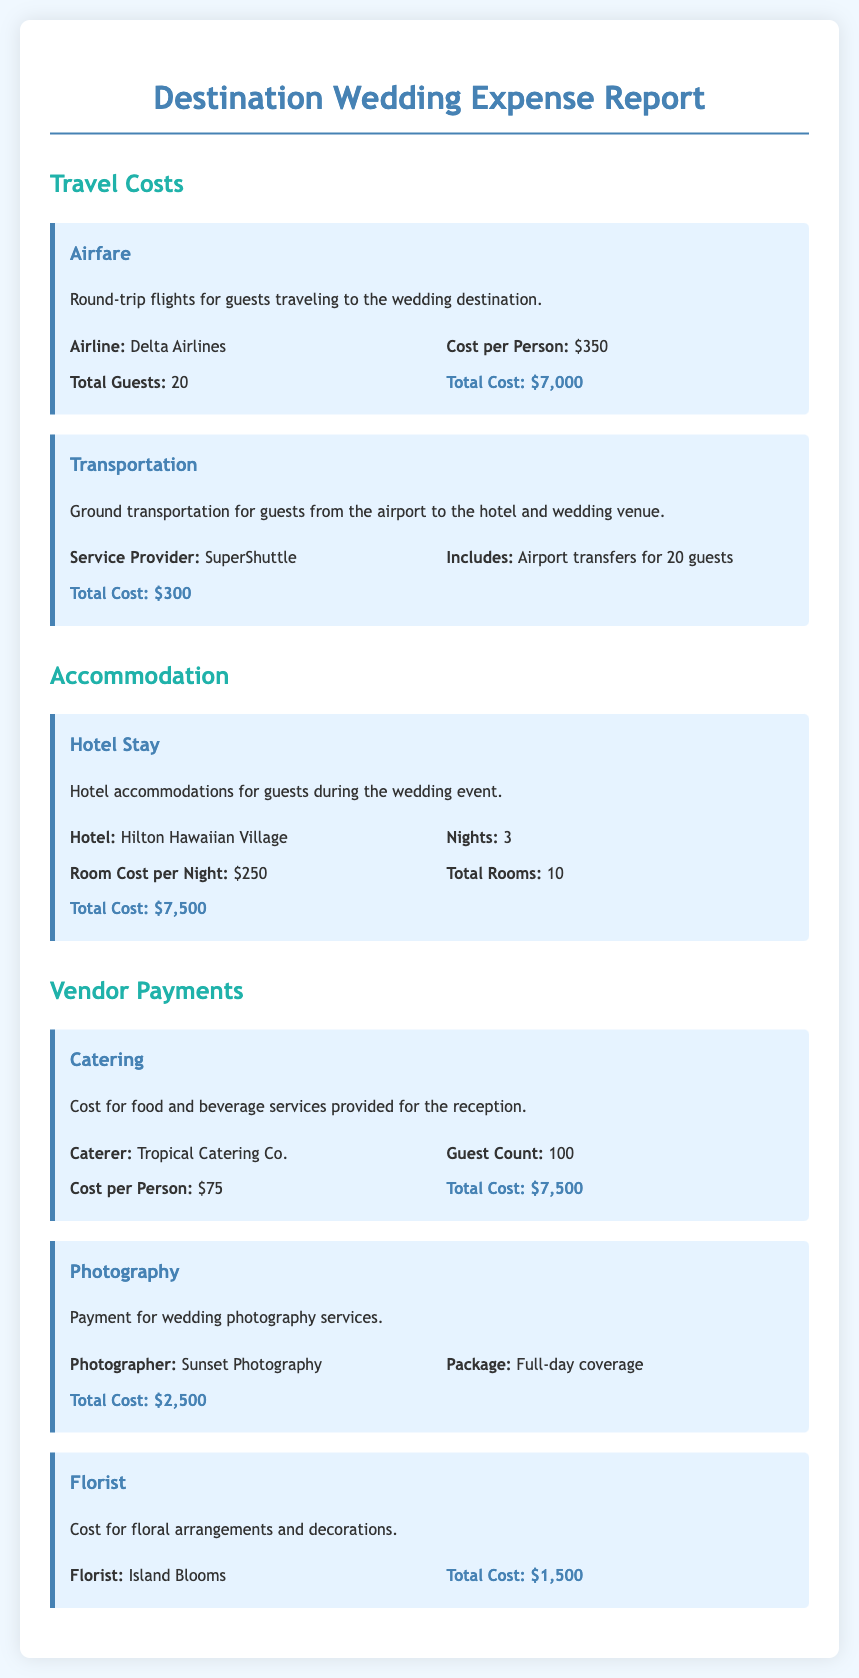What is the total cost of airfare? The total cost of airfare is computed from the cost per person and the total number of guests, which is $350 per person for 20 guests, resulting in $7,000.
Answer: $7,000 What is the ground transportation service provider? The document specifies the transportation service provider used for guests, which is SuperShuttle.
Answer: SuperShuttle How many nights do guests stay at the hotel? The hotel stay is specified to last for 3 nights for the guests attending the wedding.
Answer: 3 What is the total guest count for catering services? The document states the guest count for catering services, which is 100 guests attending the reception.
Answer: 100 What is the total cost for photography services? The expense report lists the total cost for photography services, which amounts to $2,500 for full-day coverage.
Answer: $2,500 How many rooms were booked for accommodation? The report indicates that a total of 10 rooms were booked for accommodation during the wedding event.
Answer: 10 What is the cost per night for hotel rooms? The document specifies that the cost per night for hotel rooms is $250.
Answer: $250 What is the total expense for floral arrangements? The total cost indicated for floral arrangements and decorations in the document is $1,500.
Answer: $1,500 What type of wedding coverage was purchased from the photographer? The document details that the package provided by the photographer is for full-day coverage.
Answer: Full-day coverage 